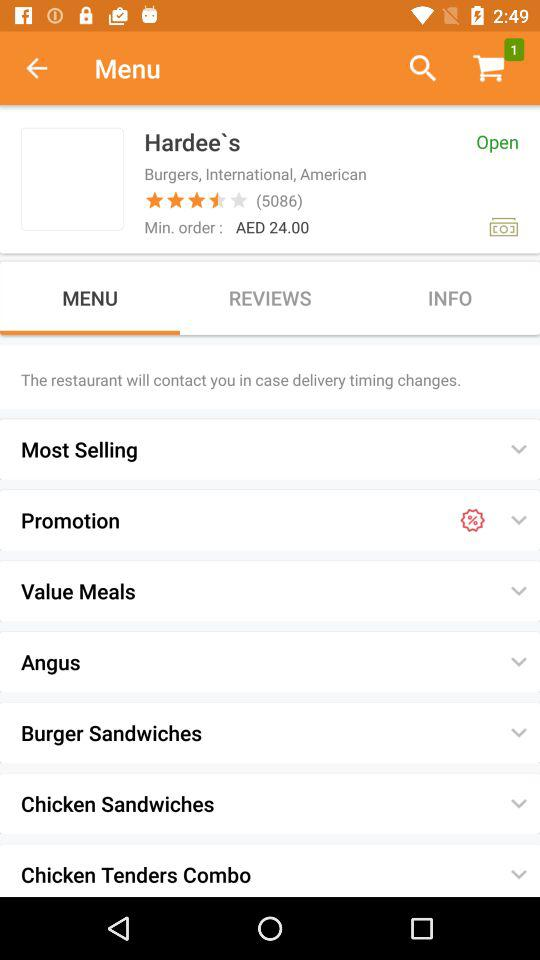What is the name of the restaurant? The name of the restaurant is "Hardee`s". 